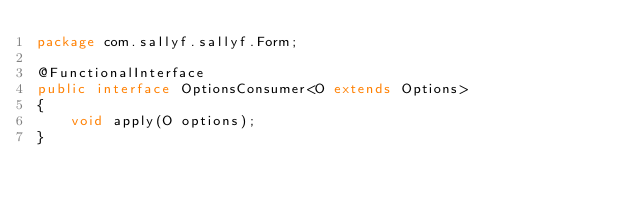Convert code to text. <code><loc_0><loc_0><loc_500><loc_500><_Java_>package com.sallyf.sallyf.Form;

@FunctionalInterface
public interface OptionsConsumer<O extends Options>
{
    void apply(O options);
}
</code> 